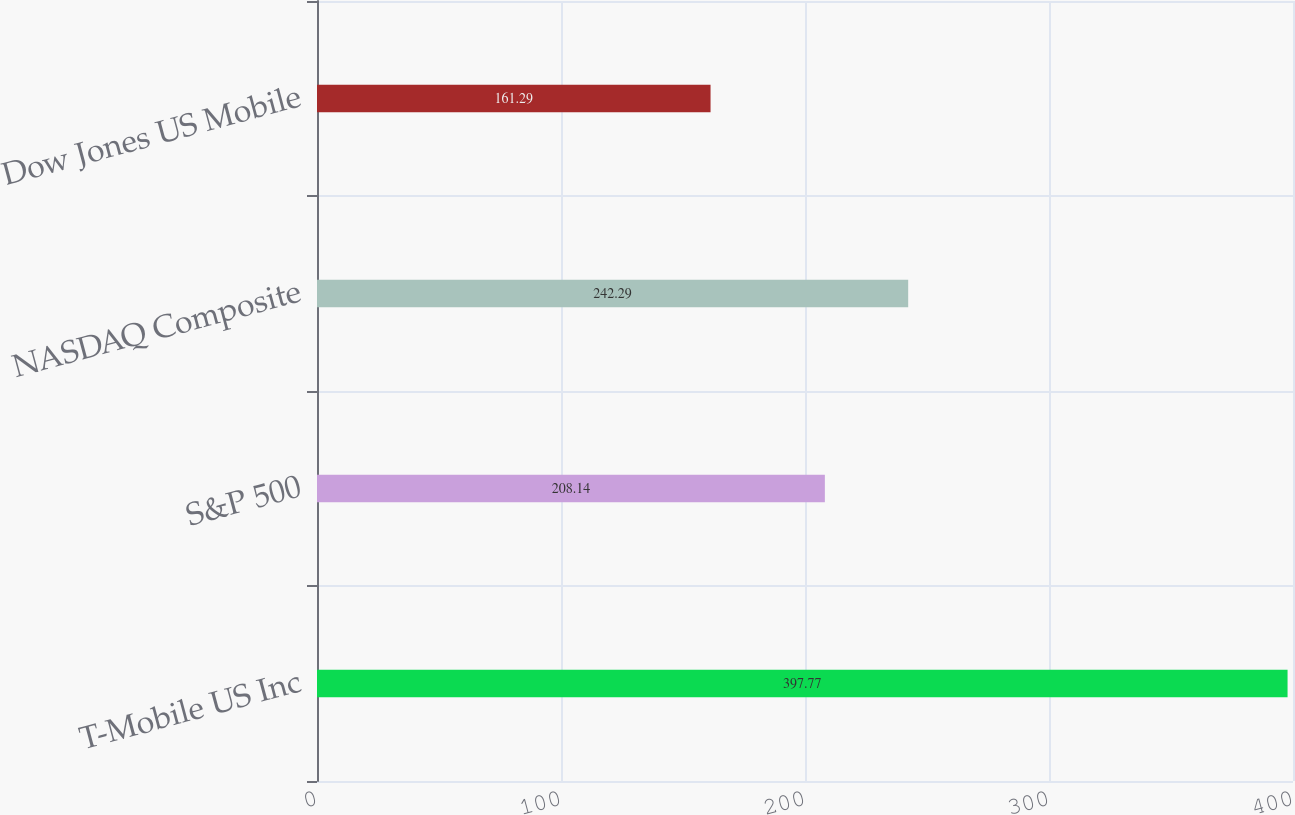Convert chart to OTSL. <chart><loc_0><loc_0><loc_500><loc_500><bar_chart><fcel>T-Mobile US Inc<fcel>S&P 500<fcel>NASDAQ Composite<fcel>Dow Jones US Mobile<nl><fcel>397.77<fcel>208.14<fcel>242.29<fcel>161.29<nl></chart> 